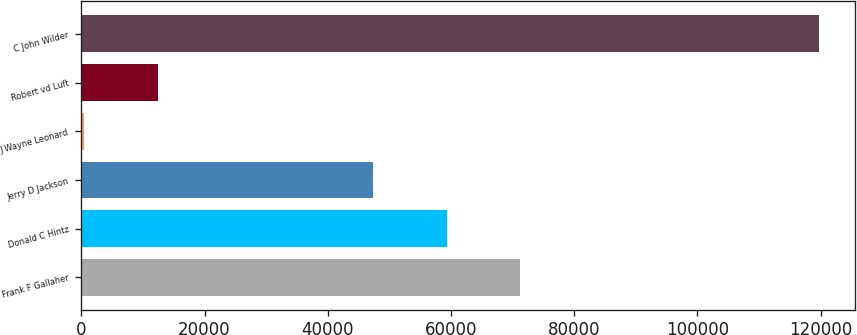Convert chart. <chart><loc_0><loc_0><loc_500><loc_500><bar_chart><fcel>Frank F Gallaher<fcel>Donald C Hintz<fcel>Jerry D Jackson<fcel>J Wayne Leonard<fcel>Robert vd Luft<fcel>C John Wilder<nl><fcel>71209.4<fcel>59291.7<fcel>47374<fcel>496<fcel>12413.7<fcel>119673<nl></chart> 